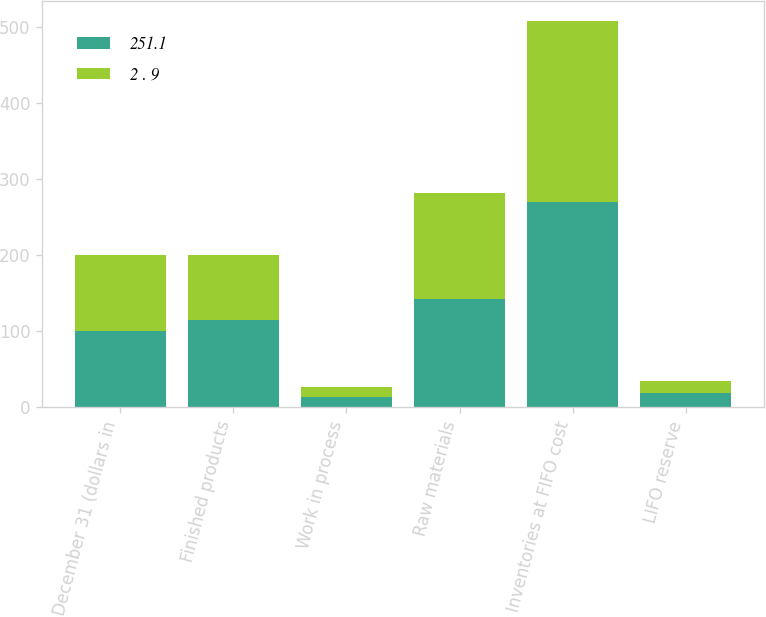<chart> <loc_0><loc_0><loc_500><loc_500><stacked_bar_chart><ecel><fcel>December 31 (dollars in<fcel>Finished products<fcel>Work in process<fcel>Raw materials<fcel>Inventories at FIFO cost<fcel>LIFO reserve<nl><fcel>251.1<fcel>99.9<fcel>114.1<fcel>13<fcel>142.4<fcel>269.5<fcel>18.4<nl><fcel>2 . 9<fcel>99.9<fcel>85.7<fcel>13.4<fcel>139.6<fcel>238.7<fcel>15.8<nl></chart> 